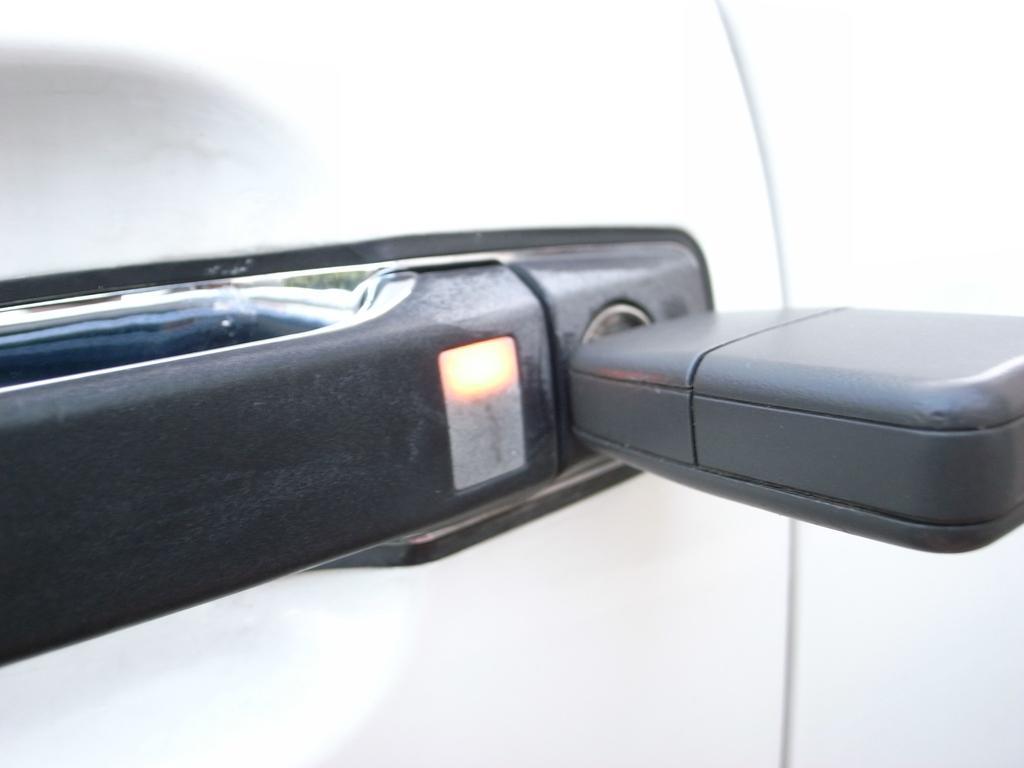In one or two sentences, can you explain what this image depicts? In this image we can see the handle of a door. 